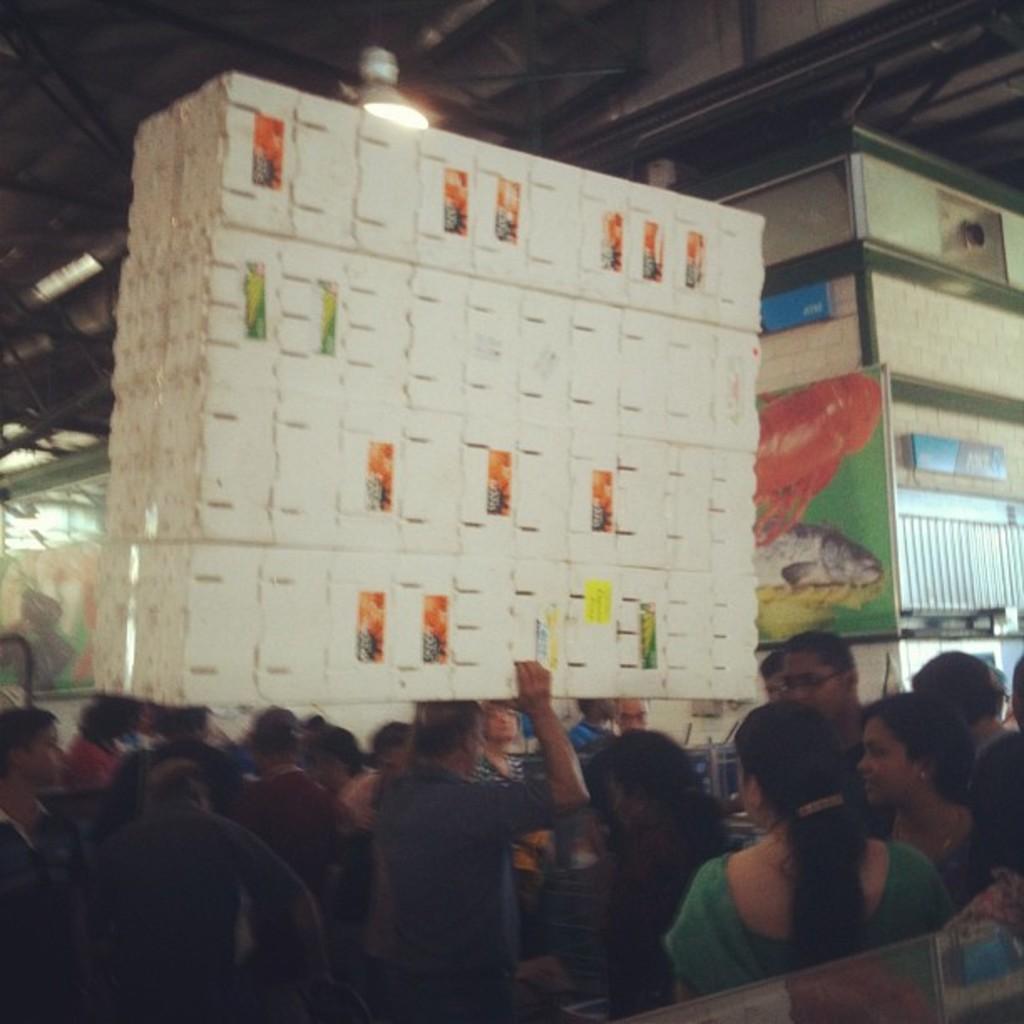Please provide a concise description of this image. In the foreground of the picture there are people. In the center of the picture there is a white color object carried by a person. On the right it is wall, to the wall there are boards and frame. On the left there is a frame to the wall. At the top there are lights to the ceiling. 